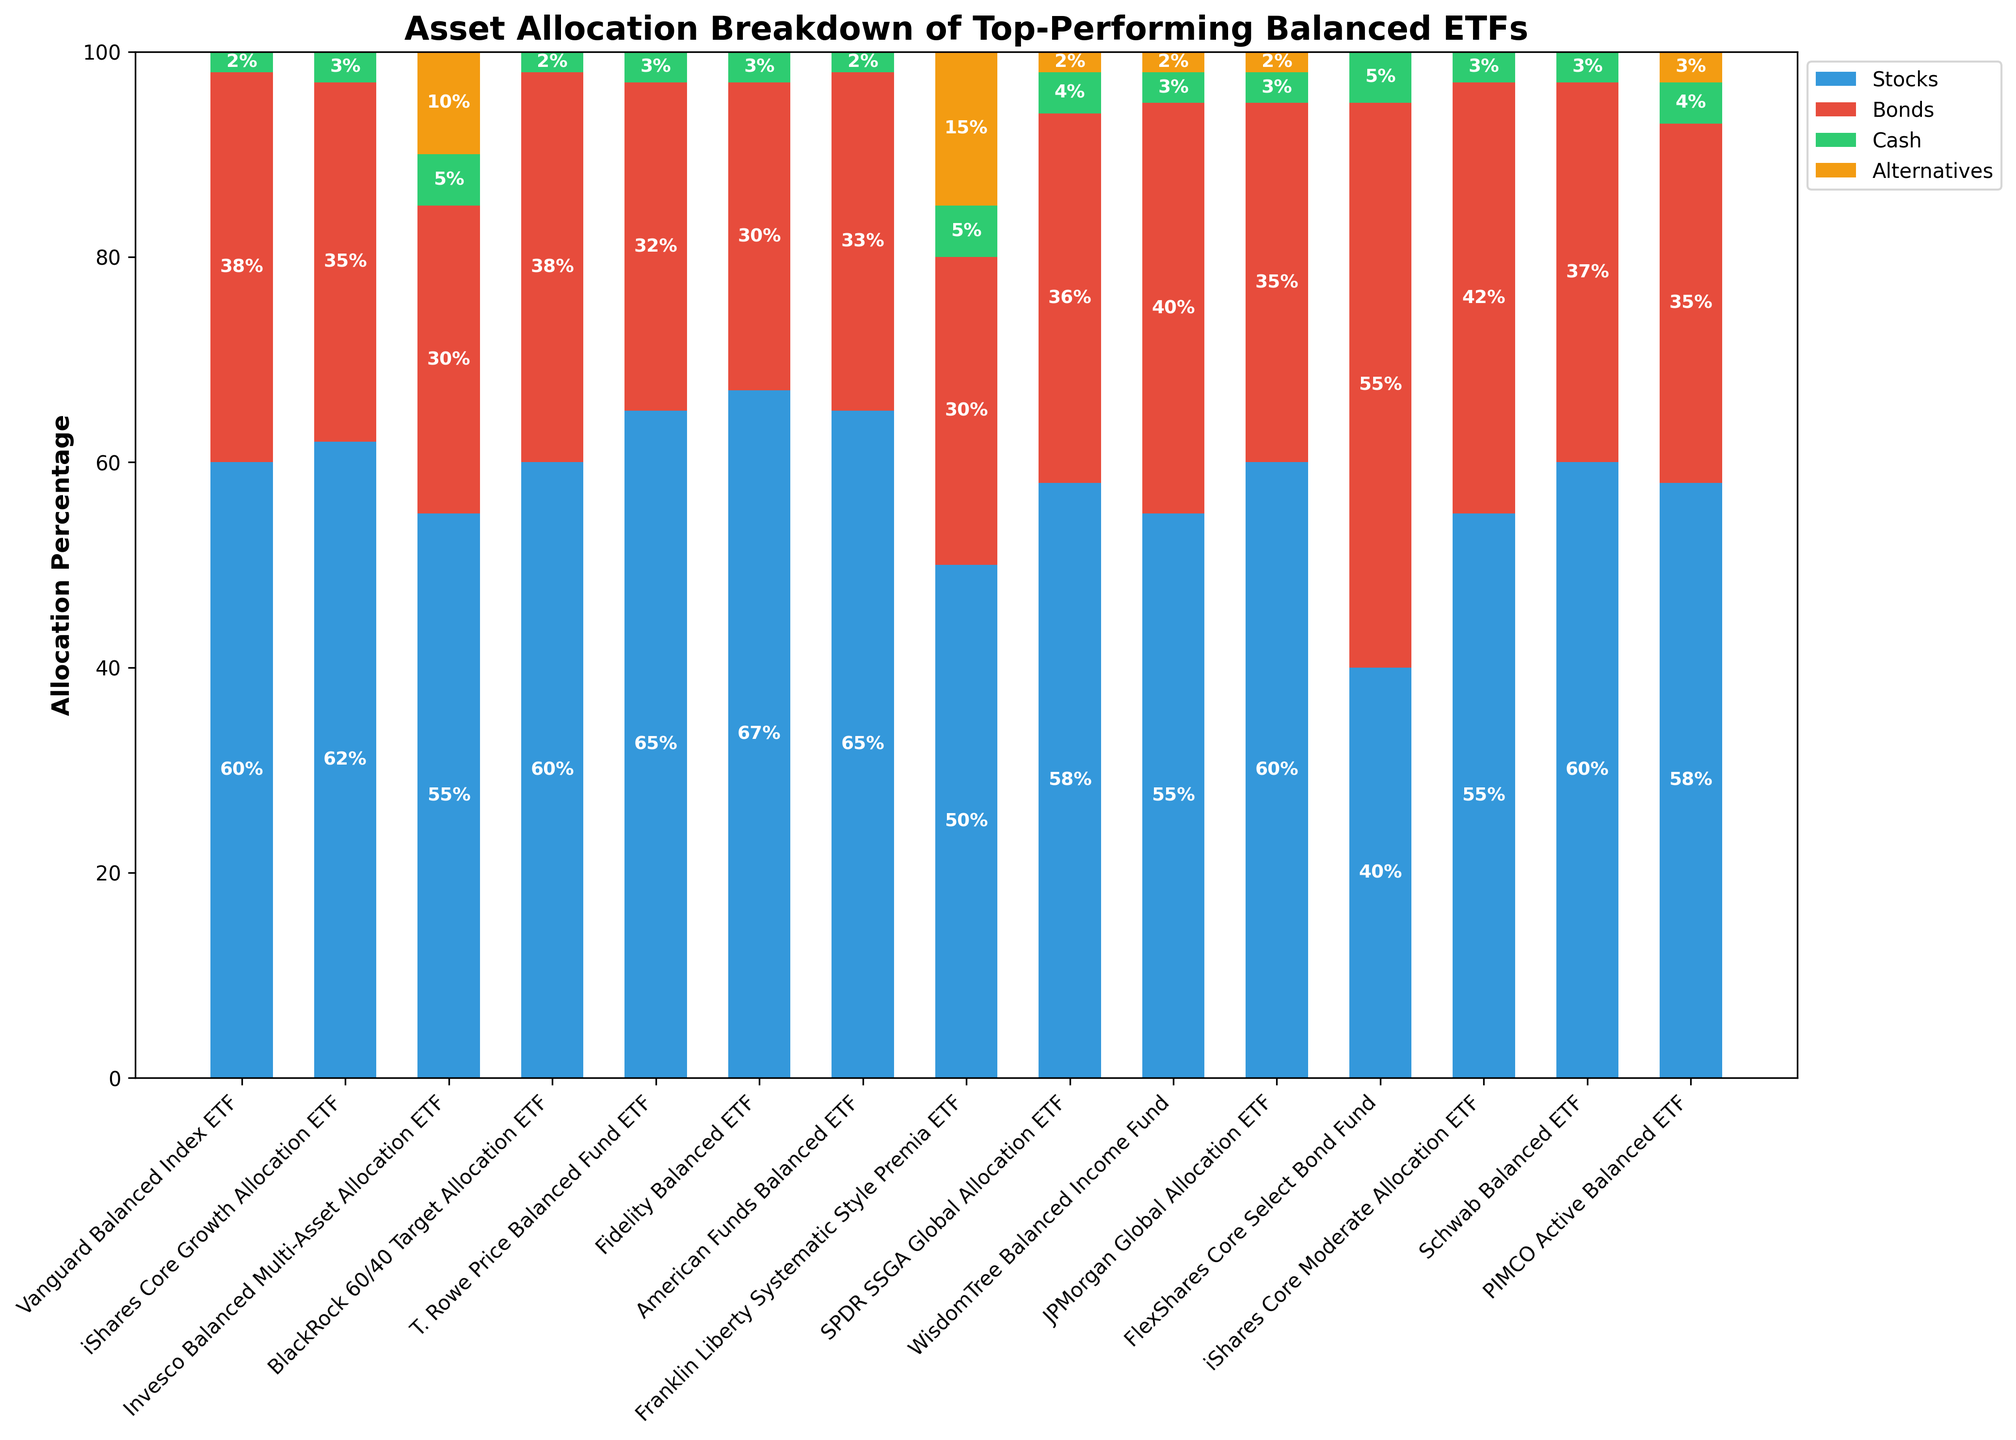Which ETF has the highest allocation in stocks? Observe the bar heights and labels for the 'Stocks' category. The Fidelity Balanced ETF has the tallest bar for stocks at 67%.
Answer: Fidelity Balanced ETF What is the combined percentage allocation to bonds and alternatives in the Invesco Balanced Multi-Asset Allocation ETF? Add the percentage allocations of bonds and alternatives for the Invesco ETF: 30% (bonds) + 10% (alternatives).
Answer: 40% Which ETF has the largest bond allocation and how much is it? Identify the ETF with the tallest bar in the 'Bonds' category, which is the FlexShares Core Select Bond Fund at 55%.
Answer: FlexShares Core Select Bond Fund, 55% Compare the cash allocations between the Invesco Balanced Multi-Asset Allocation ETF and the SPDR SSGA Global Allocation ETF, which one has a higher percentage? The Invesco Balanced Multi-Asset Allocation ETF has a cash allocation of 5%, whereas the SPDR SSGA Global Allocation ETF has a cash allocation of 4%.
Answer: Invesco Balanced Multi-Asset Allocation ETF How much is the total allocation to alternatives for the Franklin Liberty Systematic Style Premia ETF compared to the total allocation to cash in the same ETF? For the Franklin Liberty ETF, the allocation to alternatives is 15% and to cash is 5%. Subtract these values: 15% - 5%.
Answer: 10% Which ETF shows no allocation to alternatives? Look for ETFs with an alternatives bar height of 0%. These ETFs are Vanguard Balanced Index ETF, iShares Core Growth Allocation ETF, BlackRock 60/40 Target Allocation ETF, T. Rowe Price Balanced Fund ETF, Fidelity Balanced ETF, and American Funds Balanced ETF.
Answer: Multiple ETFs What is the average stock allocation across all ETFs? Sum the stock allocations of all ETFs (60 + 62 + 55 + 60 + 65 + 67 + 65 + 50 + 58 + 55 + 60 + 40 + 55 + 60 + 58) which equals 870. There are 15 ETFs. Divide the total by the number of ETFs: 870/15.
Answer: 58% Which ETF has the lowest allocation to bonds and what is this percentage? Identify the ETF with the shortest bar in the 'Bonds' category, which is the Fidelity Balanced ETF at 30%.
Answer: Fidelity Balanced ETF, 30% Compare the asset allocation breakdown of the Schwab Balanced ETF and the PIMCO Active Balanced ETF. Which one has a higher allocation in stocks? The Schwab Balanced ETF has a stock allocation of 60%, while the PIMCO Active Balanced ETF has an allocation of 58%. Therefore, the Schwab Balanced ETF has a higher allocation in stocks.
Answer: Schwab Balanced ETF What is the sum of the cash allocations for the iShares Core Growth Allocation ETF and the SPDR SSGA Global Allocation ETF? Add the cash allocation percentages of the iShares Core Growth Allocation ETF (3%) and the SPDR SSGA Global Allocation ETF (4%).
Answer: 7% 